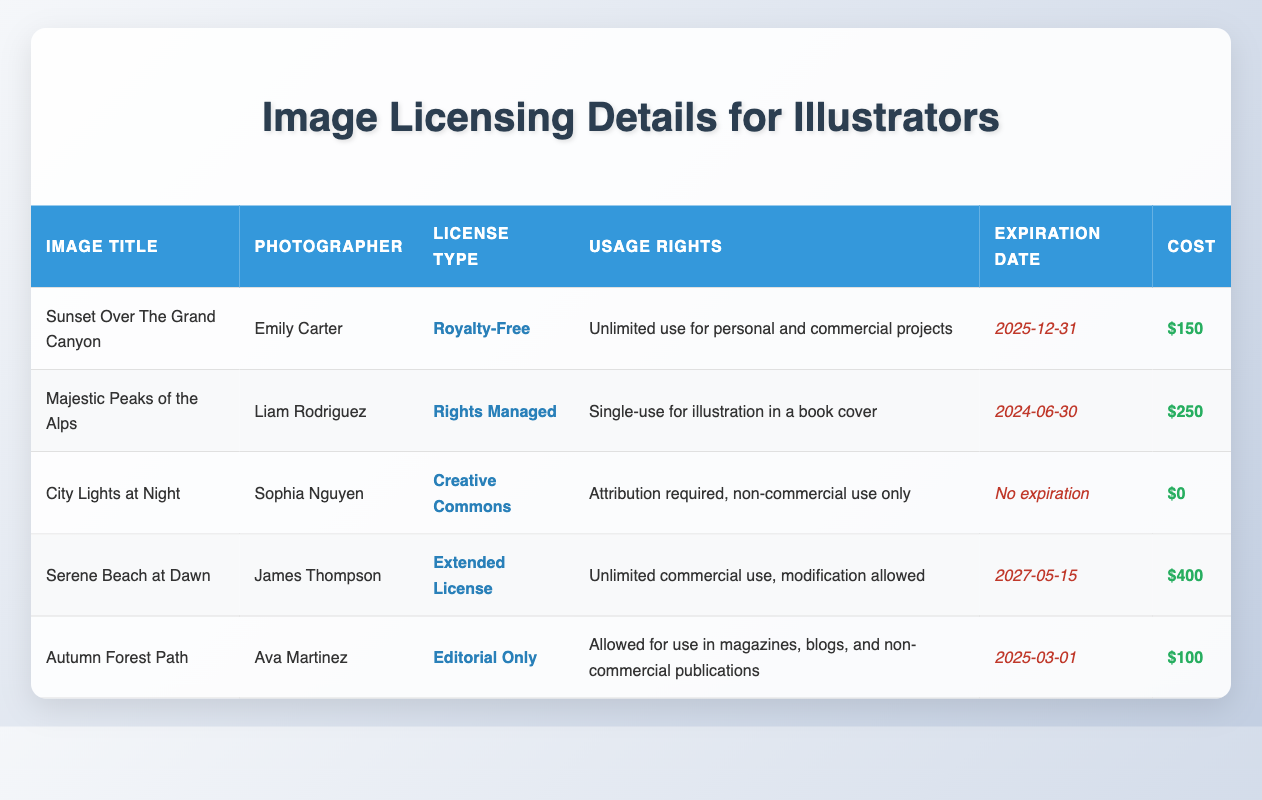What is the license type for "City Lights at Night"? By looking at the row pertaining to "City Lights at Night," we see that the license type provided is "Creative Commons".
Answer: Creative Commons Who is the photographer of "Autumn Forest Path"? The row for "Autumn Forest Path" lists the photographer as "Ava Martinez".
Answer: Ava Martinez What are the usage rights for "Serene Beach at Dawn"? In the row for "Serene Beach at Dawn", it states that the usage rights allow for "Unlimited commercial use, modification allowed".
Answer: Unlimited commercial use, modification allowed Is "Majestic Peaks of the Alps" available for unlimited use? The usage rights for "Majestic Peaks of the Alps" specify "Single-use for illustration in a book cover", therefore it is not available for unlimited use.
Answer: No What is the total cost to license "Sunset Over The Grand Canyon" and "Autumn Forest Path"? The cost of "Sunset Over The Grand Canyon" is $150 and the cost of "Autumn Forest Path" is $100. Summing these gives $150 + $100 = $250.
Answer: 250 Which image has the most expensive licensing cost? By comparing the costs of all images listed, "Serene Beach at Dawn" has the highest cost of $400, which is greater than the costs of all other images.
Answer: $400 When does the license for "Majestic Peaks of the Alps" expire? The expiration date for "Majestic Peaks of the Alps" is explicitly stated in the table as "2024-06-30".
Answer: 2024-06-30 How many images have usage rights that allow for commercial purposes? By examining the usage rights for all images, both "Sunset Over The Grand Canyon" and "Serene Beach at Dawn" allow for commercial use. Therefore, there are two images with commercial usage rights.
Answer: 2 Is "City Lights at Night" licensed for commercial use? The table indicates that the usage rights for "City Lights at Night" are "Attribution required, non-commercial use only", hence it cannot be used for commercial purposes.
Answer: No 